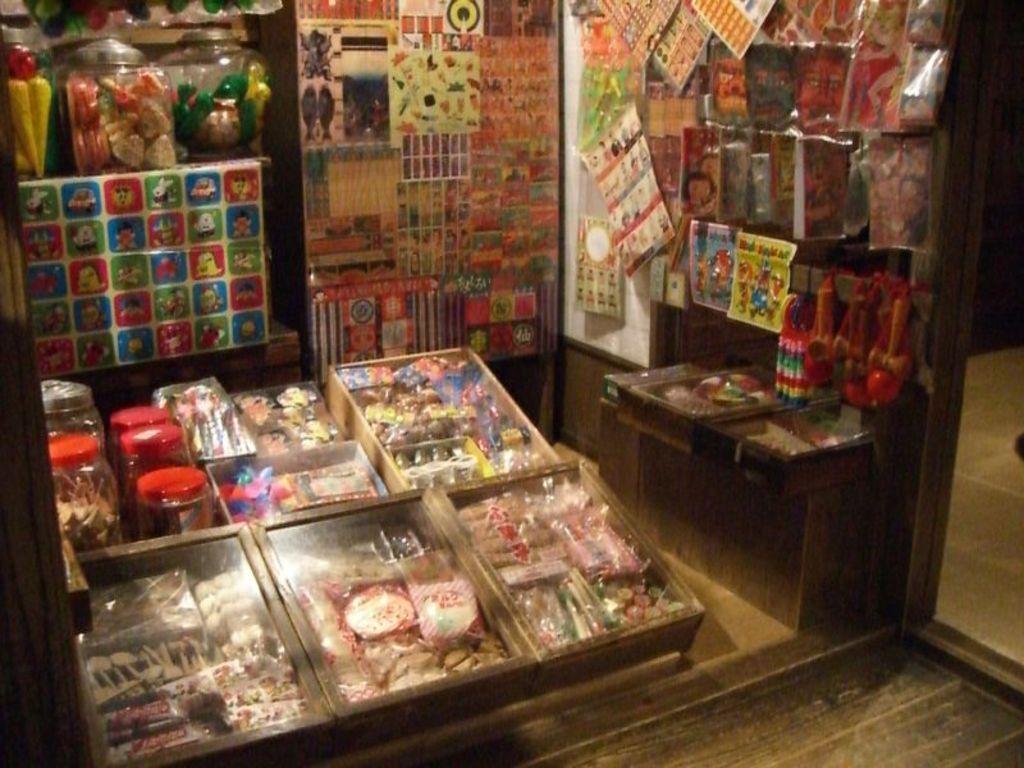Could you give a brief overview of what you see in this image? This is a picture of a shop. In this picture there are posters, jars, food items, playing things and other objects. On the right it is floor. 